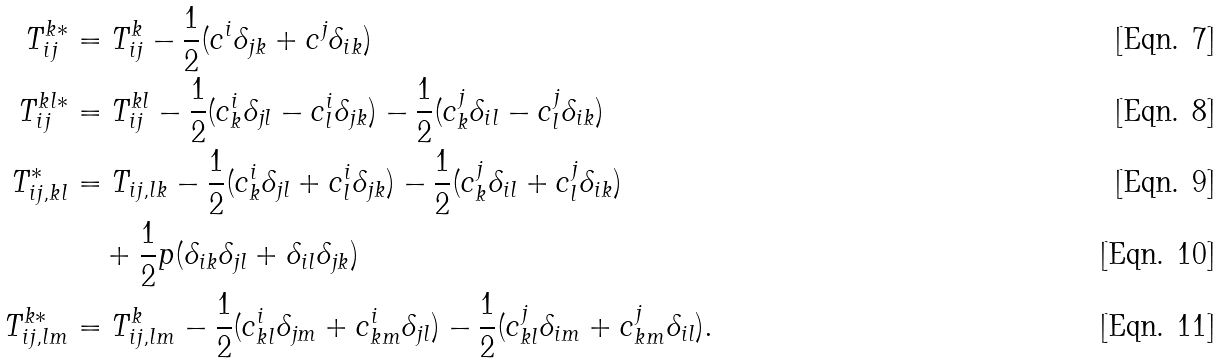Convert formula to latex. <formula><loc_0><loc_0><loc_500><loc_500>T _ { i j } ^ { k * } & = T _ { i j } ^ { k } - \frac { 1 } { 2 } ( c ^ { i } \delta _ { j k } + c ^ { j } \delta _ { i k } ) \\ T _ { i j } ^ { k l * } & = T _ { i j } ^ { k l } - \frac { 1 } { 2 } ( c ^ { i } _ { k } \delta _ { j l } - c ^ { i } _ { l } \delta _ { j k } ) - \frac { 1 } { 2 } ( c ^ { j } _ { k } \delta _ { i l } - c ^ { j } _ { l } \delta _ { i k } ) \\ T _ { i j , k l } ^ { * } & = T _ { i j , l k } - \frac { 1 } { 2 } ( c ^ { i } _ { k } \delta _ { j l } + c ^ { i } _ { l } \delta _ { j k } ) - \frac { 1 } { 2 } ( c ^ { j } _ { k } \delta _ { i l } + c ^ { j } _ { l } \delta _ { i k } ) \\ & \quad + \frac { 1 } { 2 } p ( \delta _ { i k } \delta _ { j l } + \delta _ { i l } \delta _ { j k } ) \\ T _ { i j , l m } ^ { k * } & = T _ { i j , l m } ^ { k } - \frac { 1 } { 2 } ( c ^ { i } _ { k l } \delta _ { j m } + c ^ { i } _ { k m } \delta _ { j l } ) - \frac { 1 } { 2 } ( c ^ { j } _ { k l } \delta _ { i m } + c ^ { j } _ { k m } \delta _ { i l } ) .</formula> 